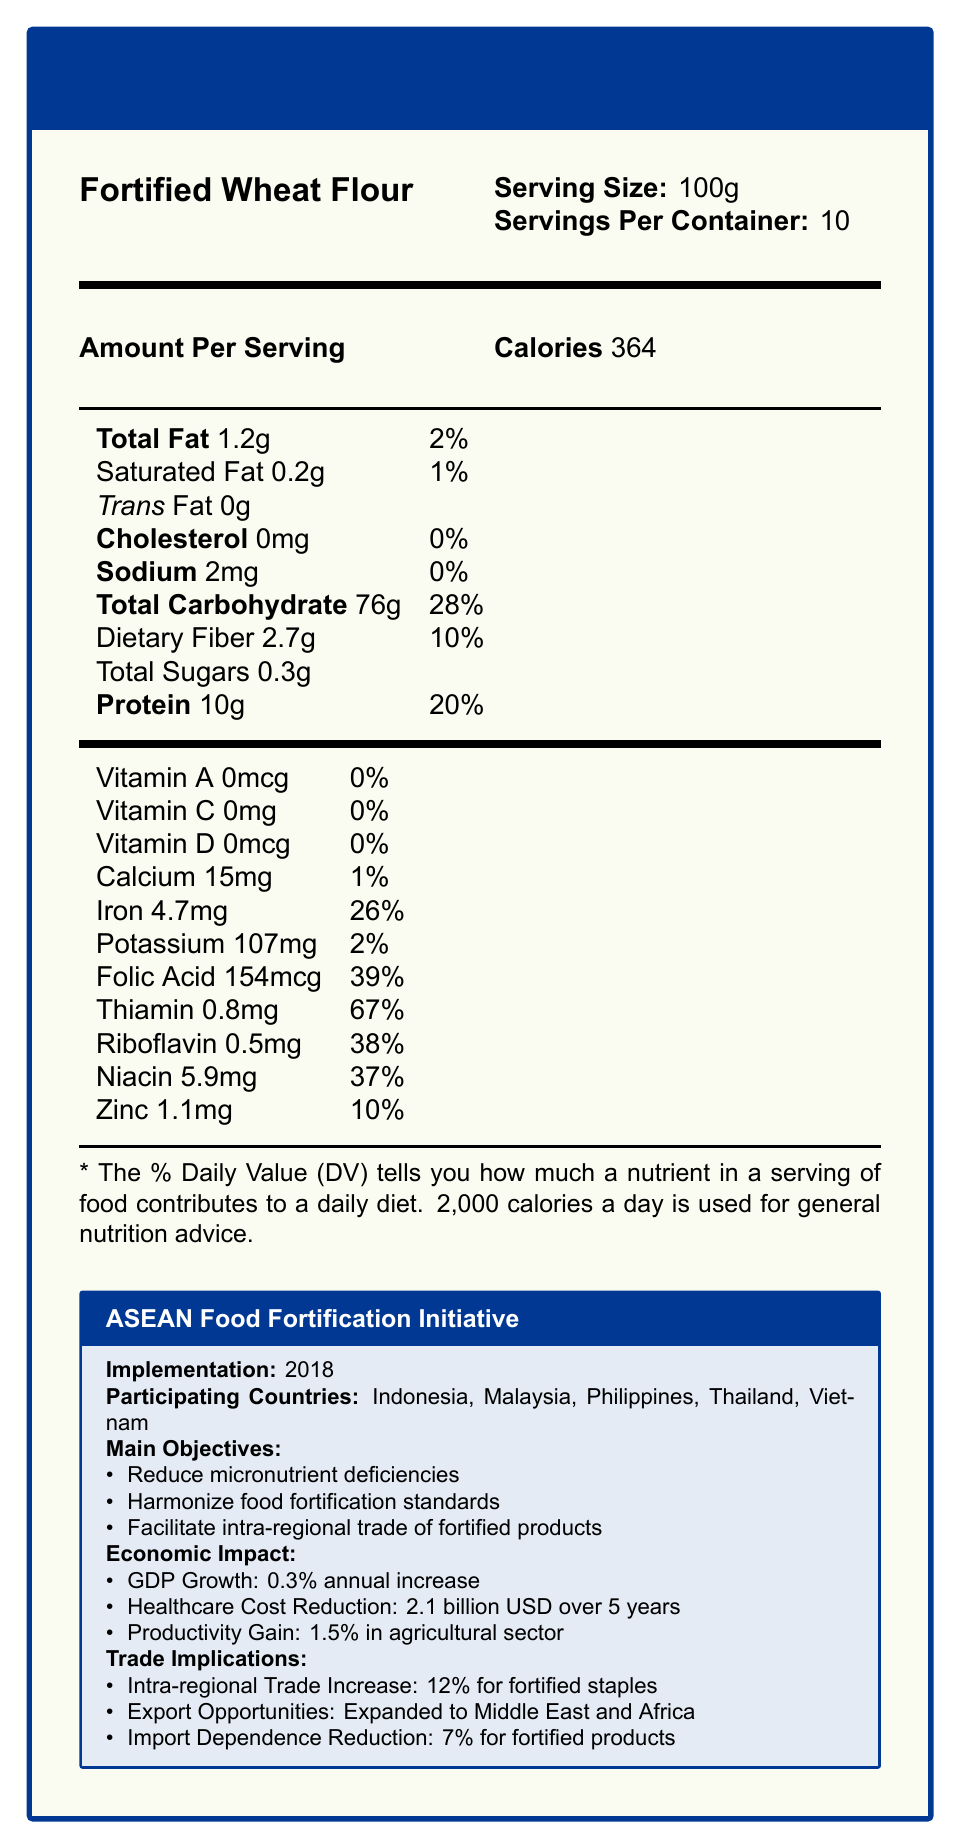what is the serving size of "Fortified Wheat Flour"? The Nutrition Facts label specifies the serving size as 100g.
Answer: 100g how many servings are there per container? The document states that there are 10 servings per container of the Fortified Wheat Flour.
Answer: 10 what is the amount of vitamin A per serving? The document lists that the amount of Vitamin A per serving is 0mcg.
Answer: 0mcg what is the daily value percentage of Thiamin in a serving of this product? According to the Nutrition Facts label, a serving of this product contains 67% of the daily value for Thiamin.
Answer: 67% how much iron is in one serving? The document states that one serving of the product contains 4.7mg of iron.
Answer: 4.7mg which participating countries are included in the ASEAN Food Fortification Initiative? A. Indonesia, Malaysia, Philippines, Thailand, Vietnam B. Indonesia, Malaysia, Singapore, Thailand, Vietnam C. Indonesia, Malaysia, Philippines, Singapore, Vietnam The document lists the participating countries as Indonesia, Malaysia, Philippines, Thailand, and Vietnam.
Answer: A. Indonesia, Malaysia, Philippines, Thailand, Vietnam what is the main objective of the ASEAN Food Fortification Initiative? A. Reduce import dependence B. Increase intra-regional trade C. Reduce micronutrient deficiencies D. All of the above The main objectives listed in the document include reducing micronutrient deficiencies, harmonizing food fortification standards, and facilitating intra-regional trade of fortified products.
Answer: D. All of the above is there any cholesterol in one serving of the Fortified Wheat Flour? The Nutrition Facts label shows that the cholesterol content is 0mg.
Answer: No describe the economic impacts mentioned in the document for the ASEAN Food Fortification Initiative. The document outlines specific economic impacts as part of the ASEAN Food Fortification Initiative, such as GDP growth, healthcare cost reduction, and productivity gains in the agricultural sector.
Answer: The economic impacts include a 0.3% annual increase in GDP growth, healthcare cost reduction of 2.1 billion USD over 5 years, and a productivity gain of 1.5% in the agricultural sector. what year was the ASEAN Food Fortification Initiative implemented? The document states that the initiative was implemented in 2018.
Answer: 2018 what are the expansion plans for the ASEAN Food Fortification Initiative by 2025? The document mentions that the expansion plans include Cambodia, Laos, and Myanmar by 2025.
Answer: Include Cambodia, Laos, and Myanmar what is the estimated market growth rate for fortified foods between 2023 and 2028? The document indicates an estimated market growth rate of 8.5% CAGR for fortified foods between 2023 and 2028.
Answer: 8.5% CAGR how much daily value percentage of dietary fiber is present in one serving of Fortified Wheat Flour? The document states that one serving contains 10% of the daily value for dietary fiber.
Answer: 10% is there any Vitamin D in the Fortified Wheat Flour? The Nutrition Facts shows that the amount of Vitamin D per serving is 0mcg, which amounts to 0% of the daily value.
Answer: No what are the challenges mentioned in the document regarding the ASEAN Food Fortification Initiative? The document lists these specific challenges in the context of implementing the ASEAN Food Fortification Initiative.
Answer: The challenges include varying regulatory frameworks, disparities in fortification technology, and consumer awareness and acceptance. what is the productivity gain in the agricultural sector due to the ASEAN Food Fortification Initiative? The document indicates that there is a productivity gain of 1.5% in the agricultural sector.
Answer: 1.5% how much folic acid is present in a serving of this product? The document states that each serving of the Fortified Wheat Flour contains 154mcg of folic acid.
Answer: 154mcg what is the policy name associated with the economic context provided? The document refers to the policy under discussion as the ASEAN Food Fortification Initiative.
Answer: ASEAN Food Fortification Initiative what total percentage of the recommended daily value of protein is in one serving of this product? The Nutrition Facts label shows that one serving contains 20% of the daily value for protein.
Answer: 20% how many countries participated in the ASEAN Food Fortification Initiative in the document? The document lists five participating countries: Indonesia, Malaysia, Philippines, Thailand, and Vietnam.
Answer: 5 what is the goal of "facilitate intra-regional trade of fortified products"? This information is explicitly stated in the document.
Answer: From the main objectives mentioned in the document, one of the goals is to facilitate intra-regional trade of fortified products. what is the total sugar content per serving of the Fortified Wheat Flour? The Nutrition Facts label lists the total sugar content per serving as 0.3g.
Answer: 0.3g how much has intra-regional trade increased for fortified staples due to the initiative? The document mentions that intra-regional trade for fortified staples has increased by 12%.
Answer: 12% what are the main objectives of the ASEAN Food Fortification Initiative? This information is listed under the main objectives in the document.
Answer: The main objectives are to reduce micronutrient deficiencies, harmonize food fortification standards, and facilitate intra-regional trade of fortified products. how much calcium is in one serving of the Fortified Wheat Flour? The Nutrition Facts label states that there is 15mg of calcium per serving.
Answer: 15mg what is the implementation year of the ASEAN Food Fortification Initiative? The document states that the initiative was implemented in the year 2018.
Answer: 2018 what's the daily value percentage of riboflavin in one serving of the Fortified Wheat Flour? According to the document, one serving contains 38% of the daily value for riboflavin.
Answer: 38% how much healthcare cost reduction is expected over 5 years due to the initiative? The document outlines an expected healthcare cost reduction of 2.1 billion USD over 5 years due to the initiative.
Answer: 2.1 billion USD what is the policy name of the economic context described? The document names the policy as the ASEAN Food Fortification Initiative.
Answer: ASEAN Food Fortification Initiative why is there a focus on biofortification of regional crops in the future prospects of the initiative? The document does not provide specific reasons for the focus on biofortification of regional crops.
Answer: Cannot be determined 